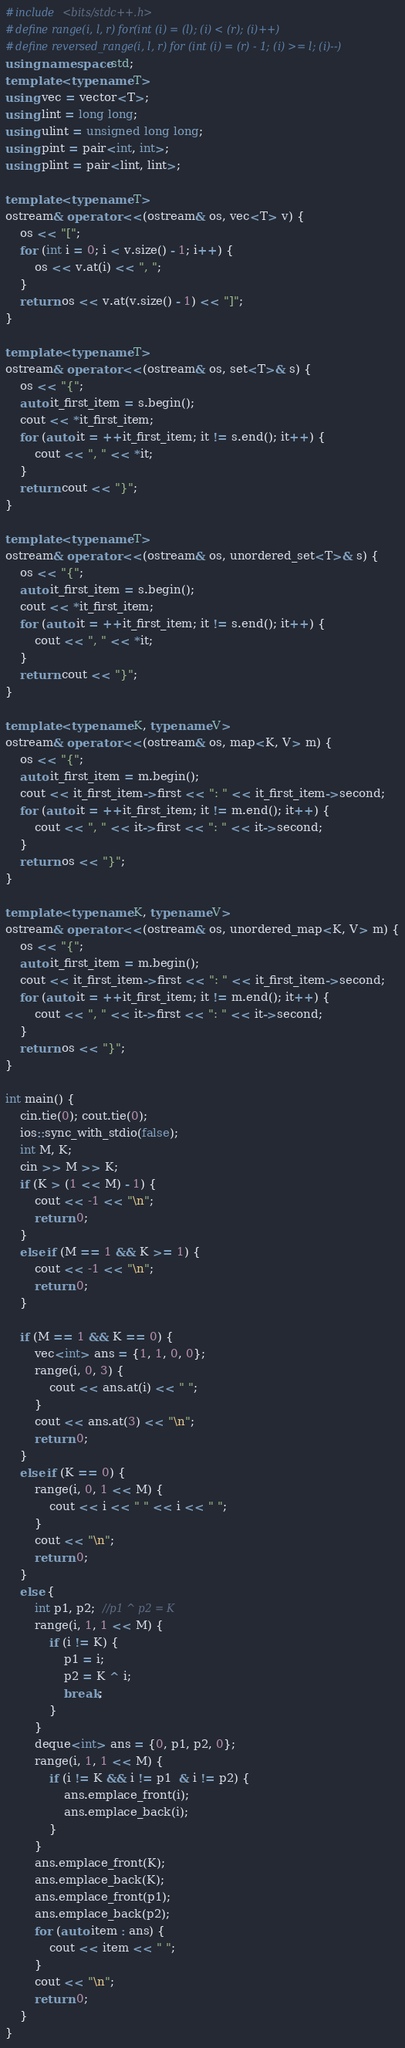<code> <loc_0><loc_0><loc_500><loc_500><_C++_>#include <bits/stdc++.h>
#define range(i, l, r) for(int (i) = (l); (i) < (r); (i)++)
#define reversed_range(i, l, r) for (int (i) = (r) - 1; (i) >= l; (i)--)
using namespace std;
template <typename T>
using vec = vector<T>;
using lint = long long;
using ulint = unsigned long long;
using pint = pair<int, int>;
using plint = pair<lint, lint>;

template <typename T>
ostream& operator <<(ostream& os, vec<T> v) {
    os << "[";
    for (int i = 0; i < v.size() - 1; i++) {
        os << v.at(i) << ", ";
    }
    return os << v.at(v.size() - 1) << "]";
}

template <typename T>
ostream& operator <<(ostream& os, set<T>& s) {
    os << "{";
    auto it_first_item = s.begin();
    cout << *it_first_item;
    for (auto it = ++it_first_item; it != s.end(); it++) {
        cout << ", " << *it;
    }
    return cout << "}";
}

template <typename T>
ostream& operator <<(ostream& os, unordered_set<T>& s) {
    os << "{";
    auto it_first_item = s.begin();
    cout << *it_first_item;
    for (auto it = ++it_first_item; it != s.end(); it++) {
        cout << ", " << *it;
    }
    return cout << "}";
}

template <typename K, typename V>
ostream& operator <<(ostream& os, map<K, V> m) {
    os << "{";
    auto it_first_item = m.begin();
    cout << it_first_item->first << ": " << it_first_item->second;
    for (auto it = ++it_first_item; it != m.end(); it++) {
        cout << ", " << it->first << ": " << it->second;
    }
    return os << "}";
}

template <typename K, typename V>
ostream& operator <<(ostream& os, unordered_map<K, V> m) {
    os << "{";
    auto it_first_item = m.begin();
    cout << it_first_item->first << ": " << it_first_item->second;
    for (auto it = ++it_first_item; it != m.end(); it++) {
        cout << ", " << it->first << ": " << it->second;
    }
    return os << "}";
}

int main() {
    cin.tie(0); cout.tie(0);
    ios::sync_with_stdio(false);
    int M, K;
    cin >> M >> K;
    if (K > (1 << M) - 1) {
        cout << -1 << "\n";
        return 0;
    }
    else if (M == 1 && K >= 1) {
        cout << -1 << "\n";
        return 0;
    }

    if (M == 1 && K == 0) {
        vec<int> ans = {1, 1, 0, 0};
        range(i, 0, 3) {
            cout << ans.at(i) << " ";
        }
        cout << ans.at(3) << "\n";
        return 0;
    }
    else if (K == 0) {
        range(i, 0, 1 << M) {
            cout << i << " " << i << " ";
        }
        cout << "\n";
        return 0;
    }
    else {
        int p1, p2;  //p1 ^ p2 = K
        range(i, 1, 1 << M) {
            if (i != K) {
                p1 = i;
                p2 = K ^ i;
                break;
            }
        }
        deque<int> ans = {0, p1, p2, 0};
        range(i, 1, 1 << M) {
            if (i != K && i != p1  & i != p2) {
                ans.emplace_front(i);
                ans.emplace_back(i);
            }
        }
        ans.emplace_front(K);
        ans.emplace_back(K);
        ans.emplace_front(p1);
        ans.emplace_back(p2);
        for (auto item : ans) {
            cout << item << " ";
        }
        cout << "\n";
        return 0;
    }
}</code> 